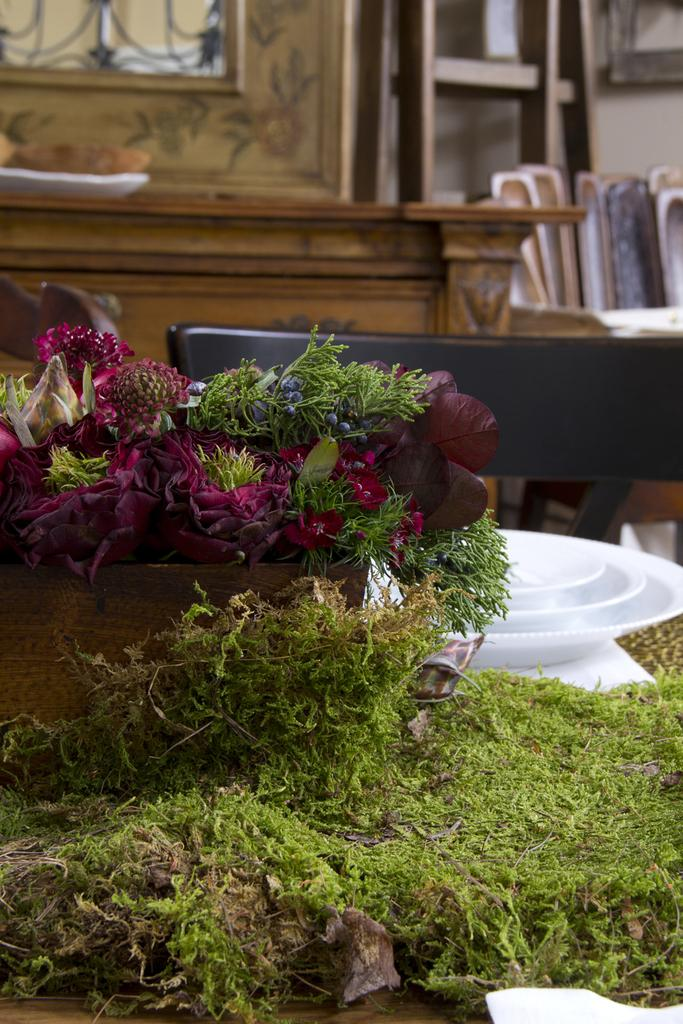What type of surface is covered with grass in the image? The grass is on a surface, but the specific type of surface is not mentioned in the facts. What is inside the basket in the image? There is a basket with flowers in the image. What objects are placed on the surface with grass? There are plates on the surface in the image. What can be seen in the background of the image? There is a chair and wooden items in the background of the image. Are the flowers in the basket on fire in the image? No, there is no indication that the flowers or any other objects in the image are on fire. Can you see someone's toes under the chair in the background? There is no mention of any people or body parts in the image, so it is not possible to see someone's toes under the chair. 